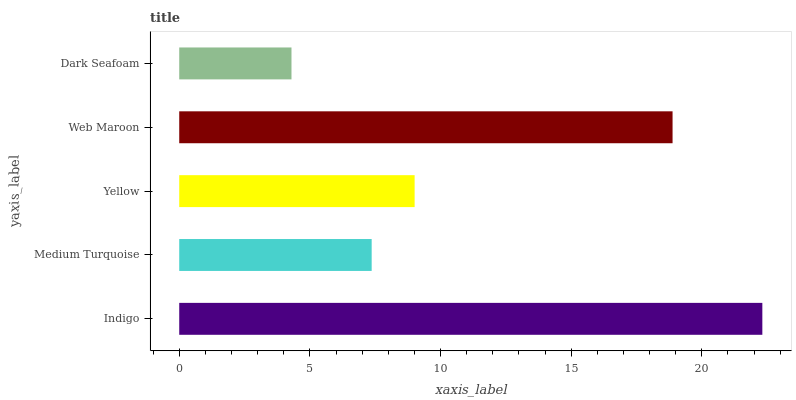Is Dark Seafoam the minimum?
Answer yes or no. Yes. Is Indigo the maximum?
Answer yes or no. Yes. Is Medium Turquoise the minimum?
Answer yes or no. No. Is Medium Turquoise the maximum?
Answer yes or no. No. Is Indigo greater than Medium Turquoise?
Answer yes or no. Yes. Is Medium Turquoise less than Indigo?
Answer yes or no. Yes. Is Medium Turquoise greater than Indigo?
Answer yes or no. No. Is Indigo less than Medium Turquoise?
Answer yes or no. No. Is Yellow the high median?
Answer yes or no. Yes. Is Yellow the low median?
Answer yes or no. Yes. Is Web Maroon the high median?
Answer yes or no. No. Is Dark Seafoam the low median?
Answer yes or no. No. 